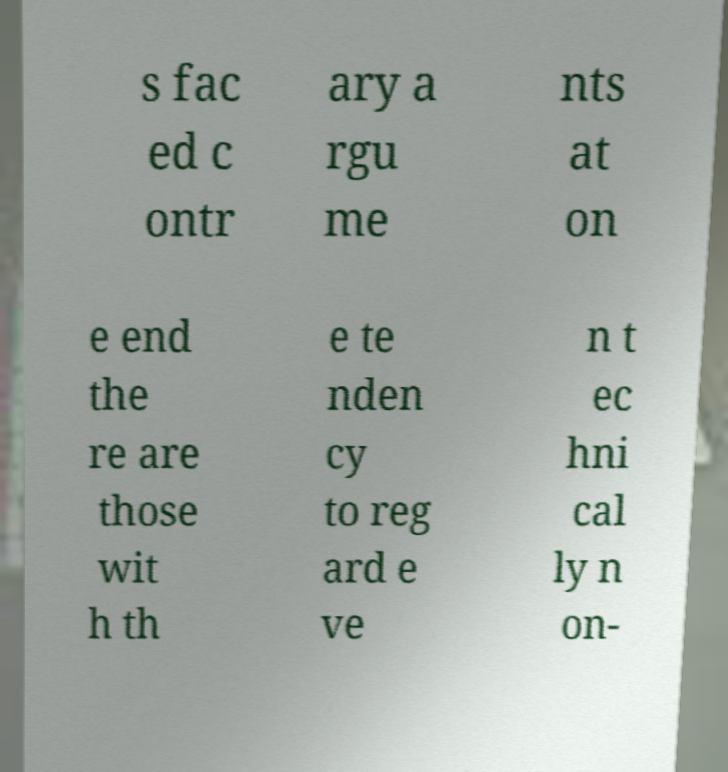There's text embedded in this image that I need extracted. Can you transcribe it verbatim? s fac ed c ontr ary a rgu me nts at on e end the re are those wit h th e te nden cy to reg ard e ve n t ec hni cal ly n on- 